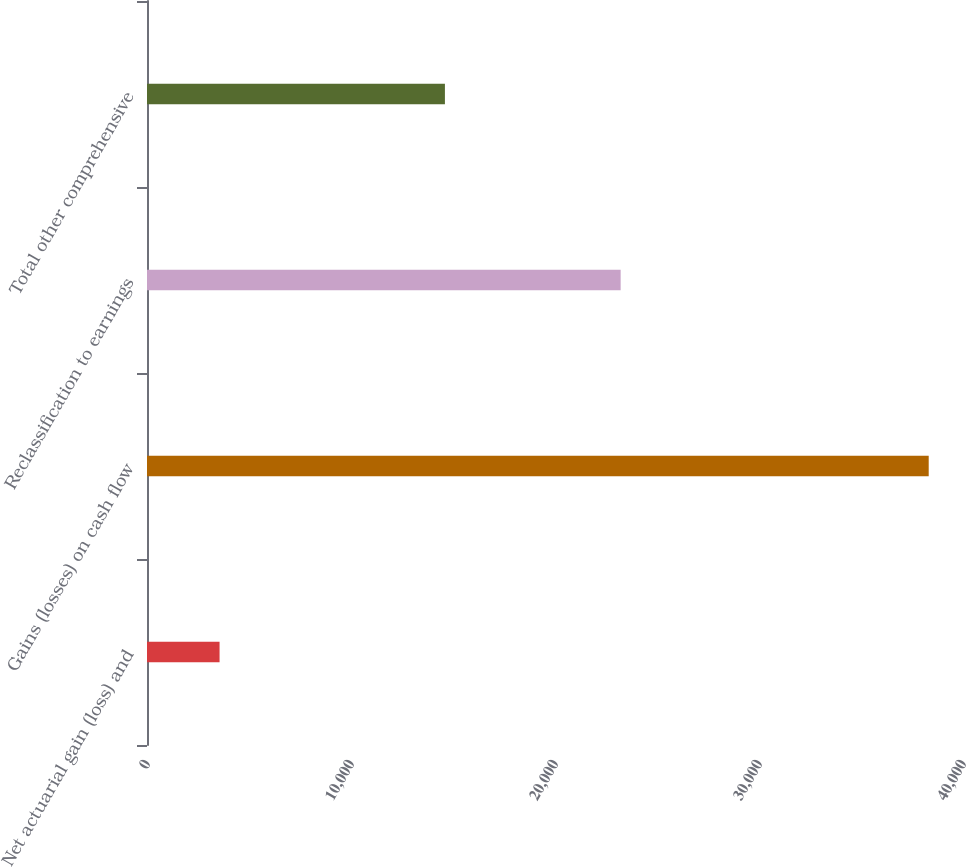Convert chart to OTSL. <chart><loc_0><loc_0><loc_500><loc_500><bar_chart><fcel>Net actuarial gain (loss) and<fcel>Gains (losses) on cash flow<fcel>Reclassification to earnings<fcel>Total other comprehensive<nl><fcel>3557<fcel>38319<fcel>23218<fcel>14604<nl></chart> 